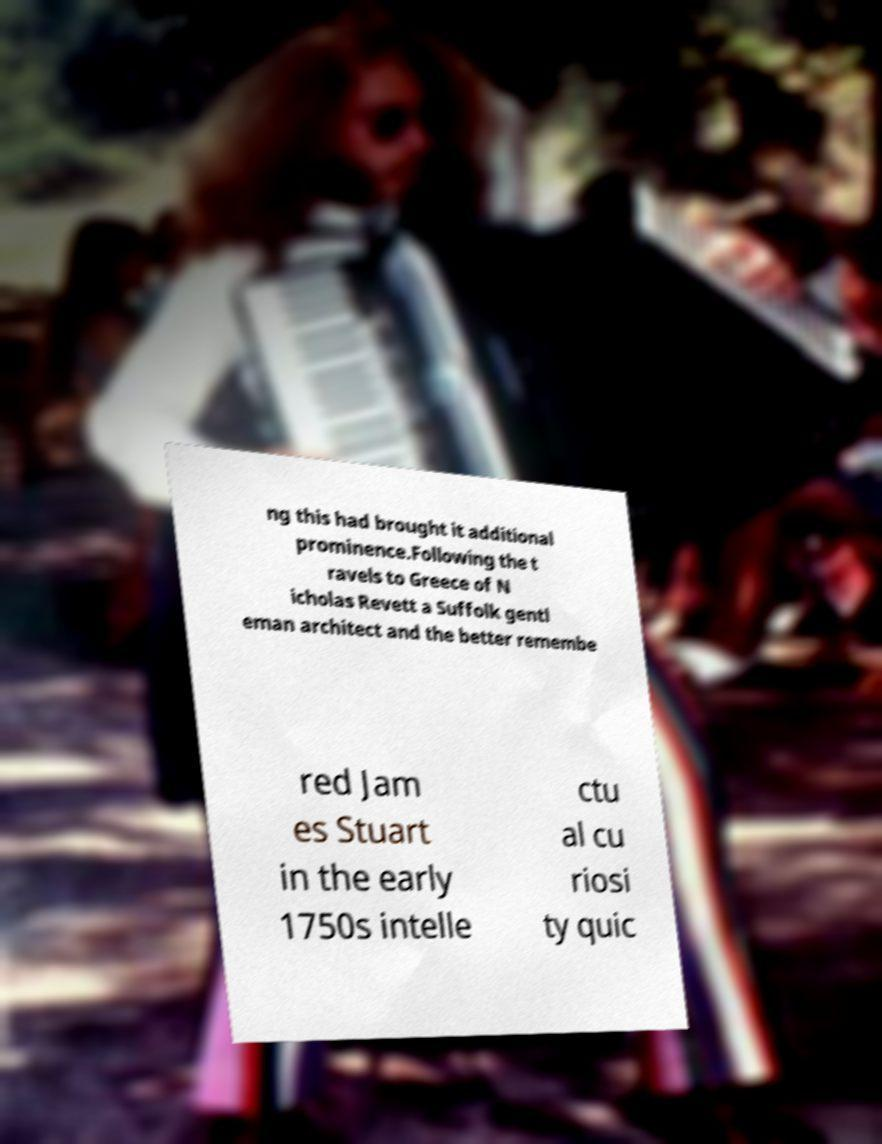For documentation purposes, I need the text within this image transcribed. Could you provide that? ng this had brought it additional prominence.Following the t ravels to Greece of N icholas Revett a Suffolk gentl eman architect and the better remembe red Jam es Stuart in the early 1750s intelle ctu al cu riosi ty quic 